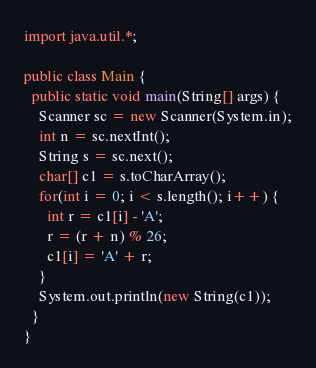<code> <loc_0><loc_0><loc_500><loc_500><_Java_>import java.util.*;

public class Main {
  public static void main(String[] args) {
    Scanner sc = new Scanner(System.in);
    int n = sc.nextInt();
    String s = sc.next();
    char[] c1 = s.toCharArray();
    for(int i = 0; i < s.length(); i++) {
      int r = c1[i] - 'A';
      r = (r + n) % 26;
      c1[i] = 'A' + r;
    }
    System.out.println(new String(c1));
  }
}</code> 